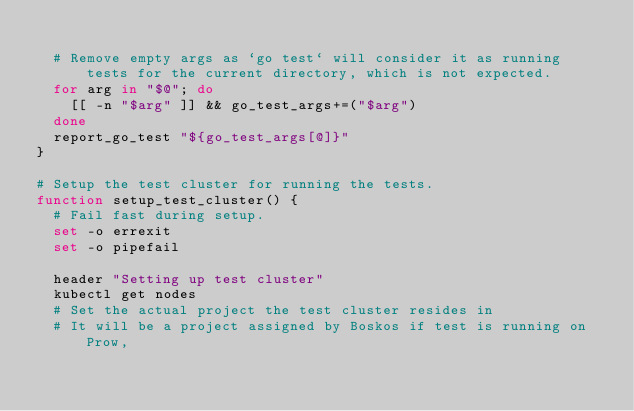Convert code to text. <code><loc_0><loc_0><loc_500><loc_500><_Bash_>
  # Remove empty args as `go test` will consider it as running tests for the current directory, which is not expected.
  for arg in "$@"; do
    [[ -n "$arg" ]] && go_test_args+=("$arg")
  done
  report_go_test "${go_test_args[@]}"
}

# Setup the test cluster for running the tests.
function setup_test_cluster() {
  # Fail fast during setup.
  set -o errexit
  set -o pipefail

  header "Setting up test cluster"
  kubectl get nodes
  # Set the actual project the test cluster resides in
  # It will be a project assigned by Boskos if test is running on Prow,</code> 